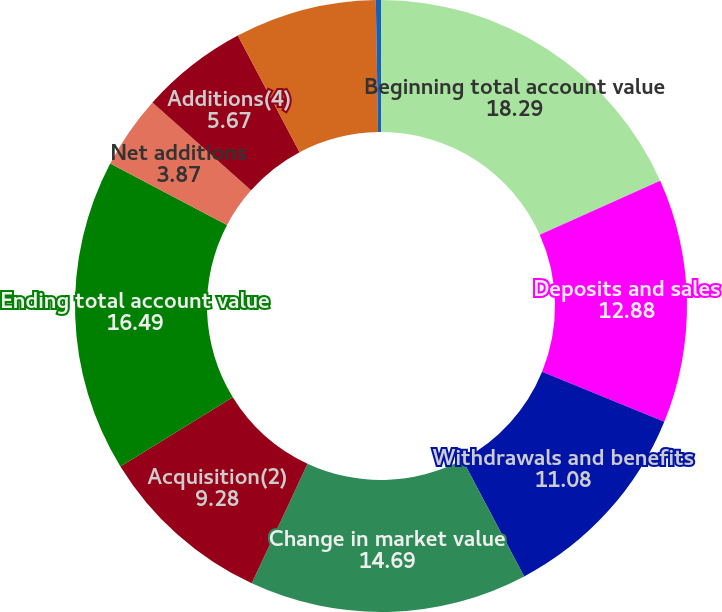Convert chart. <chart><loc_0><loc_0><loc_500><loc_500><pie_chart><fcel>Beginning total account value<fcel>Deposits and sales<fcel>Withdrawals and benefits<fcel>Change in market value<fcel>Acquisition(2)<fcel>Ending total account value<fcel>Net additions<fcel>Additions(4)<fcel>Withdrawals and benefits(5)<fcel>Other(6)<nl><fcel>18.29%<fcel>12.88%<fcel>11.08%<fcel>14.69%<fcel>9.28%<fcel>16.49%<fcel>3.87%<fcel>5.67%<fcel>7.48%<fcel>0.27%<nl></chart> 